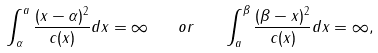Convert formula to latex. <formula><loc_0><loc_0><loc_500><loc_500>\int _ { \alpha } ^ { a } \frac { ( x - \alpha ) ^ { 2 } } { c ( x ) } d x = \infty \quad o r \quad \int _ { a } ^ { \beta } \frac { ( \beta - x ) ^ { 2 } } { c ( x ) } d x = \infty ,</formula> 